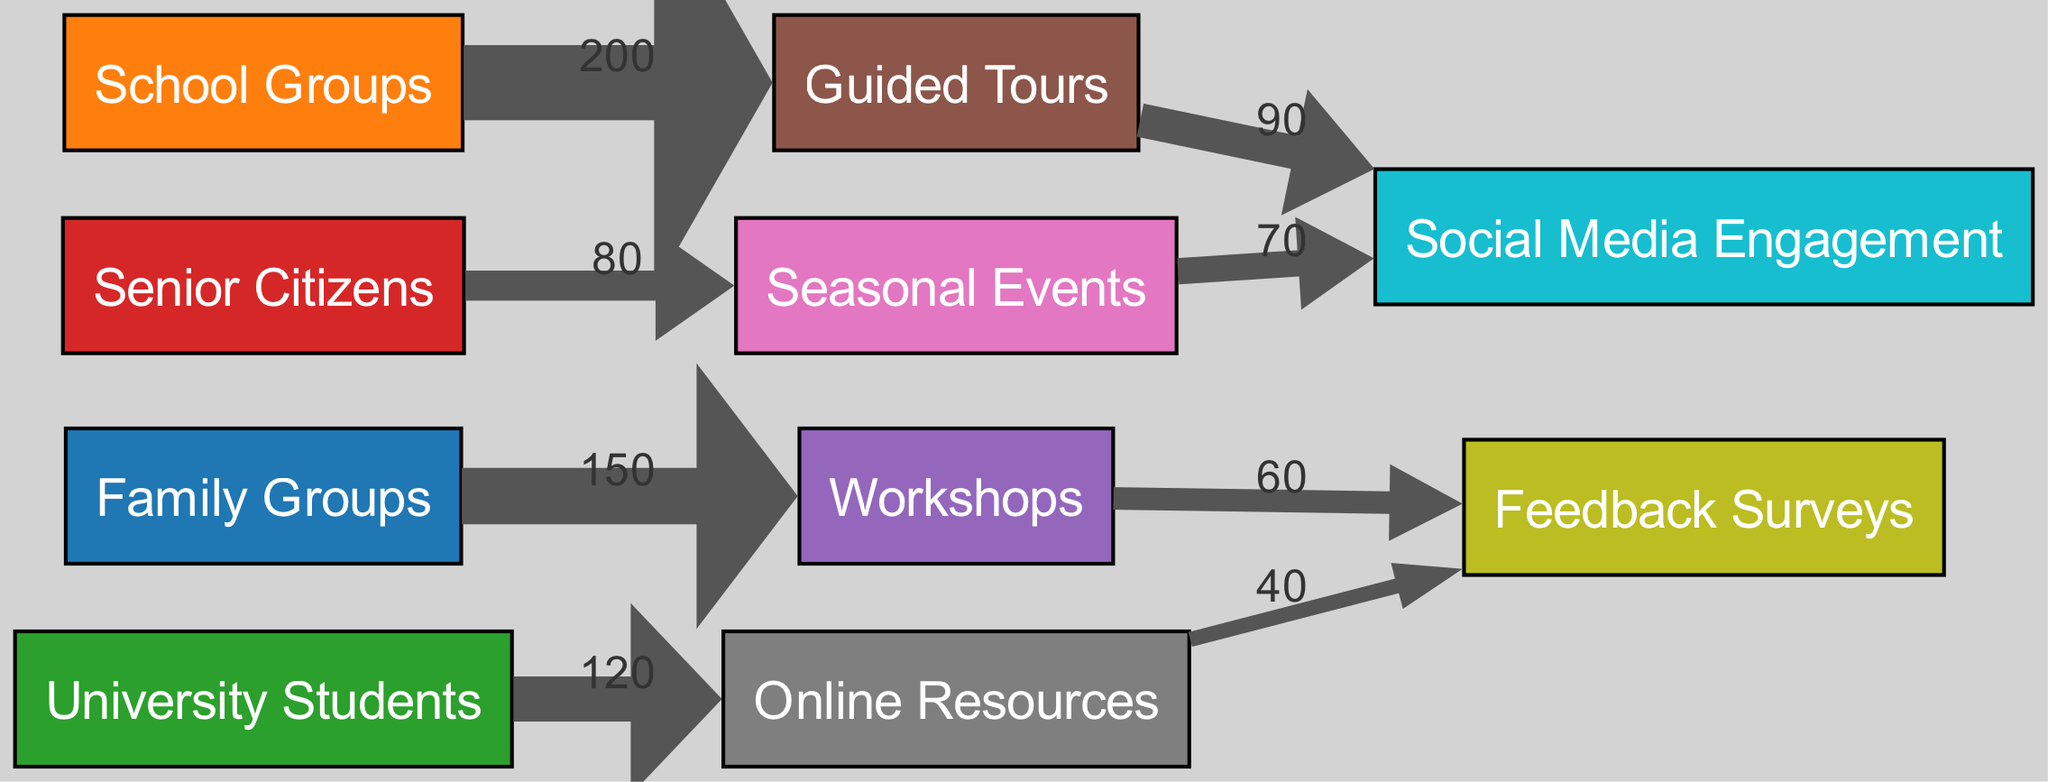What is the total number of nodes in the diagram? The diagram has a list of nodes defined under the "nodes" section in the data. By counting the items listed, we see that there are 10 distinct nodes.
Answer: 10 Which demographic group is most engaged in workshops? The link from "Family Groups" to "Workshops" shows a value of 150, indicating that Family Groups are the most engaged demographic in workshops compared to others.
Answer: Family Groups How many people engaged in feedback surveys from workshops? The link from "Workshops" to "Feedback Surveys" indicates a value of 60, meaning 60 people provided feedback after attending workshops.
Answer: 60 Which educational program received the highest engagement from school groups? The diagram shows that "School Groups" are linked to "Guided Tours" with a value of 200, which is higher than their engagement with other programs.
Answer: Guided Tours What is the total engagement of university students with online resources? The link from "University Students" to "Online Resources" has a value of 120, representing the total engagement from this demographic with these resources.
Answer: 120 Which program has the lowest engagement from senior citizens? The lowest value linked from "Senior Citizens" is to "Seasonal Events" with a value of 80, indicating this is the least engaged program for this demographic.
Answer: Seasonal Events What are the two main outputs of workshops based on the flows in this diagram? Looking at the edges from "Workshops", they lead to "Feedback Surveys" (value 60) and do not show any other output besides this. Thus, the main output is feedback surveys.
Answer: Feedback Surveys How many total people from guided tours engaged with social media? The flow from "Guided Tours" to "Social Media Engagement" indicates a value of 90, which represents the total number of people who engaged through this channel.
Answer: 90 How many people provided feedback on online resources? The link from "Online Resources" to "Feedback Surveys" shows a value of 40, indicating that 40 people provided feedback on these resources.
Answer: 40 